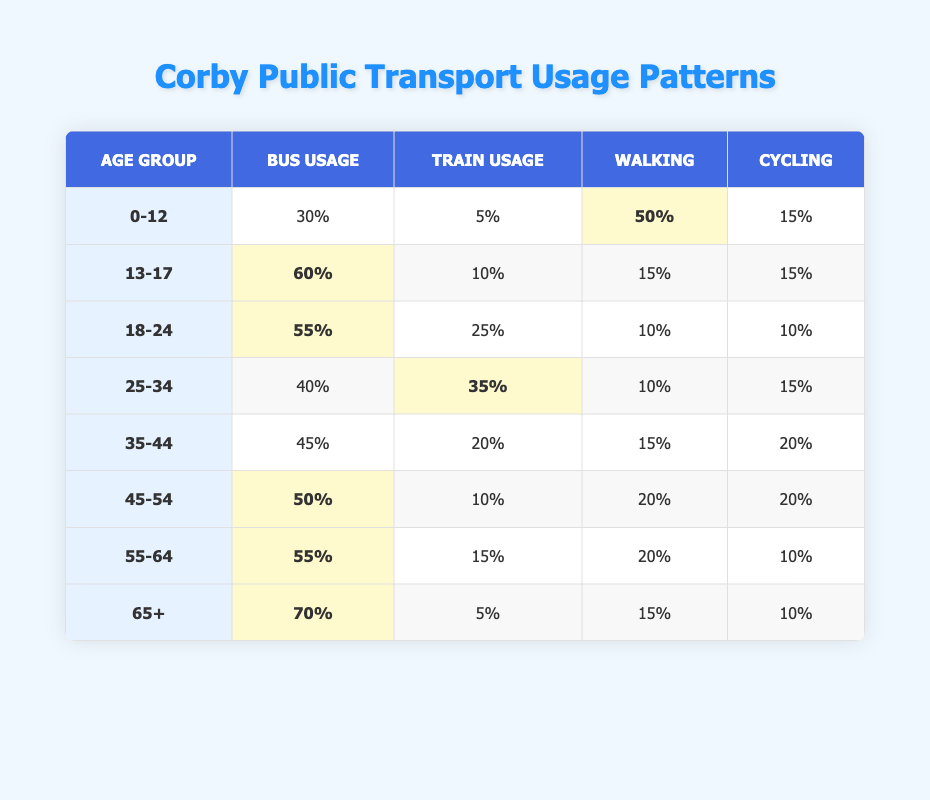What percentage of the 0-12 age group uses the bus? Looking at the table, the bus usage percentage for the 0-12 age group is directly provided in the first row.
Answer: 30% What is the percentage of train usage for the 65+ age group? The table shows that the train usage percentage for the 65+ age group is found in the last row.
Answer: 5% Which age group has the highest percentage of bus usage? To determine this, I compare the bus usage percentages of all age groups. The 65+ age group has the highest at 70%.
Answer: 65+ What is the average bus usage percentage across all age groups? I sum the bus usage percentages (30 + 60 + 55 + 40 + 45 + 50 + 55 + 70 = 410) and divide by the total number of age groups (8), which results in an average of 51.25%.
Answer: 51.25% Is it true that the 25-34 age group has a higher train usage than the 18-24 age group? By comparing the train usage percentages in the table, the 25-34 age group has 35% while the 18-24 age group has 25%, so the statement is true.
Answer: Yes Which age group relies more on walking than cycling? I check each age group for walking and cycling percentages. The age groups 0-12, 35-44, and 45-54 all use walking more than cycling.
Answer: 0-12, 35-44, 45-54 What percentage of 45-54 age group members either walk or cycle? I sum the walking (20%) and cycling (20%) percentages for the 45-54 age group, which equals 40%.
Answer: 40% Which age group has the lowest percentage of biking? I review the bike usage percentages across all age groups, and the 55-64 age group has the lowest at 10%.
Answer: 55-64 